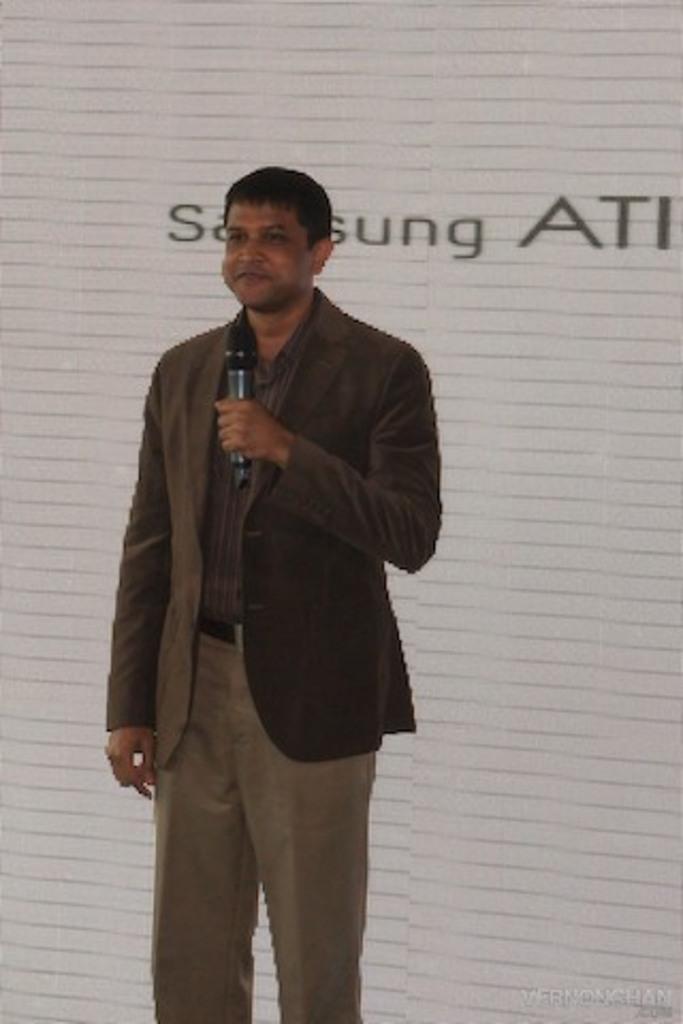Describe this image in one or two sentences. In the image in the center, we can see one person standing and holding a microphone and he is smiling, which we can see on his face. In the background there is a wall and a banner. 